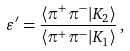<formula> <loc_0><loc_0><loc_500><loc_500>\varepsilon ^ { \prime } = \frac { \langle \pi ^ { + } \pi ^ { - } | K _ { 2 } \rangle } { \langle \pi ^ { + } \pi ^ { - } | K _ { 1 } \rangle } \, ,</formula> 